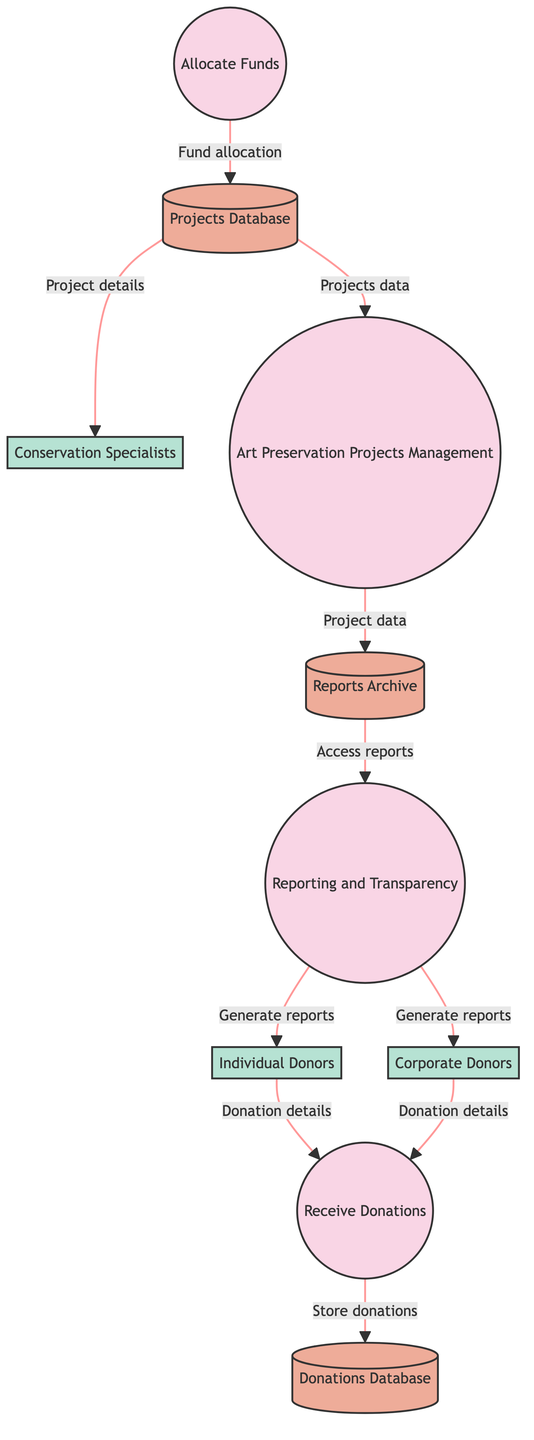What is the first process in the diagram? The first process is indicated in the flow as receiving donations, which is labeled as "Receive Donations" in the diagram.
Answer: Receive Donations How many external entities are there? By counting the visible external entities in the diagram, there are three entities: Individual Donors, Corporate Donors, and Conservation Specialists.
Answer: 3 What type of data does the Donations Database store? The Donations Database stores all information related to donor transactions and donations, labeled "Store of all donation transactions and donor information" in the diagram.
Answer: Donation transactions and donor information Which process directly receives data from both individual and corporate donors? The process receiving data from both individual and corporate donors is "Receive Donations" as it is connected to both external entities.
Answer: Receive Donations What is the connection between the Projects Database and the Art Preservation Projects Management process? The Projects Database provides the "Projects data for management," which is used by the Art Preservation Projects Management process.
Answer: Projects data for management What does the Reporting and Transparency process provide to individual donors? The Reporting and Transparency process generates reports that are specifically sent to individual donors, which is reflected in the flow labeled "Report generating for individual donors."
Answer: Reports Which data store contains historical reports? The Reports Archive is specifically labeled as the store containing all generated reports for historical reference and transparency purposes.
Answer: Reports Archive Which external entity benefits from project details in the diagram? The external entity that receives project details is the Conservation Specialists, as indicated by the flow labeled "Project details for conservation specialists."
Answer: Conservation Specialists How many processes are in the diagram? By counting, there are four processes shown in the diagram: Receive Donations, Allocate Funds, Art Preservation Projects Management, and Reporting and Transparency.
Answer: 4 What is the output of the Allocate Funds process? The output of the Allocate Funds process is the allocation of funds to the Projects Database, indicated by the flow labeled "Fund allocation to projects."
Answer: Fund allocation to projects 